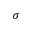Convert formula to latex. <formula><loc_0><loc_0><loc_500><loc_500>\sigma</formula> 